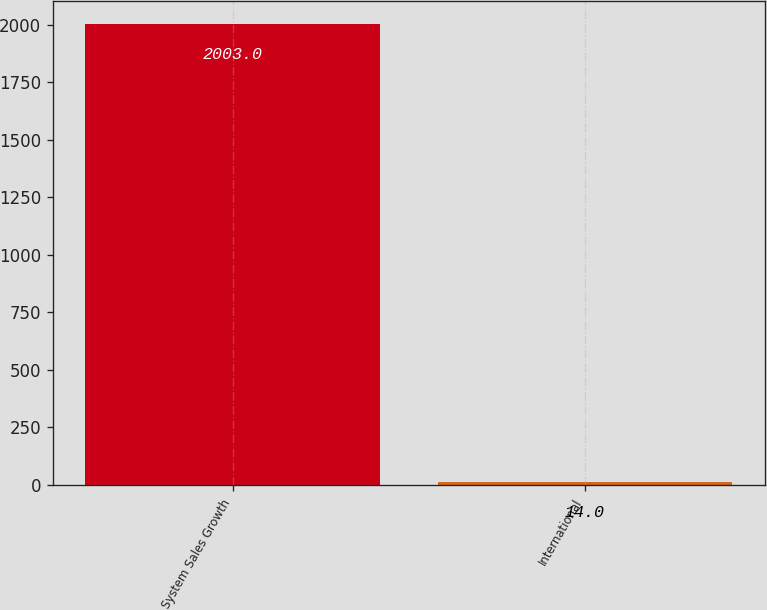Convert chart to OTSL. <chart><loc_0><loc_0><loc_500><loc_500><bar_chart><fcel>System Sales Growth<fcel>International<nl><fcel>2003<fcel>14<nl></chart> 